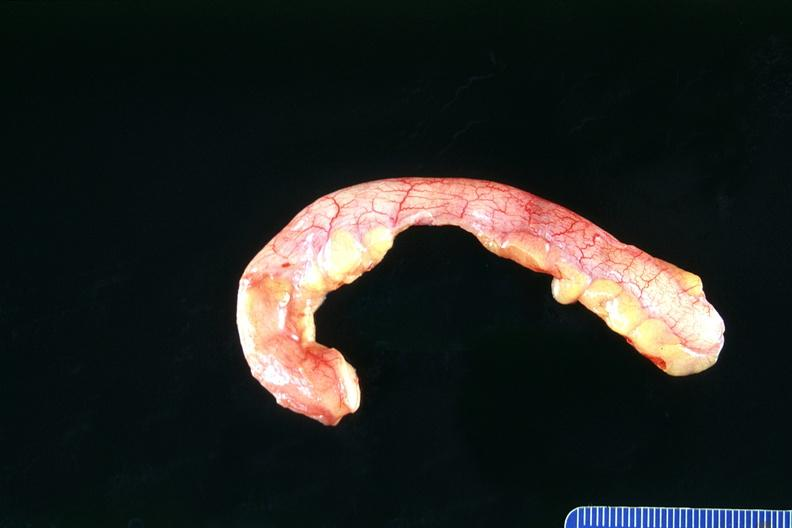what does this image show?
Answer the question using a single word or phrase. Normal appendix 